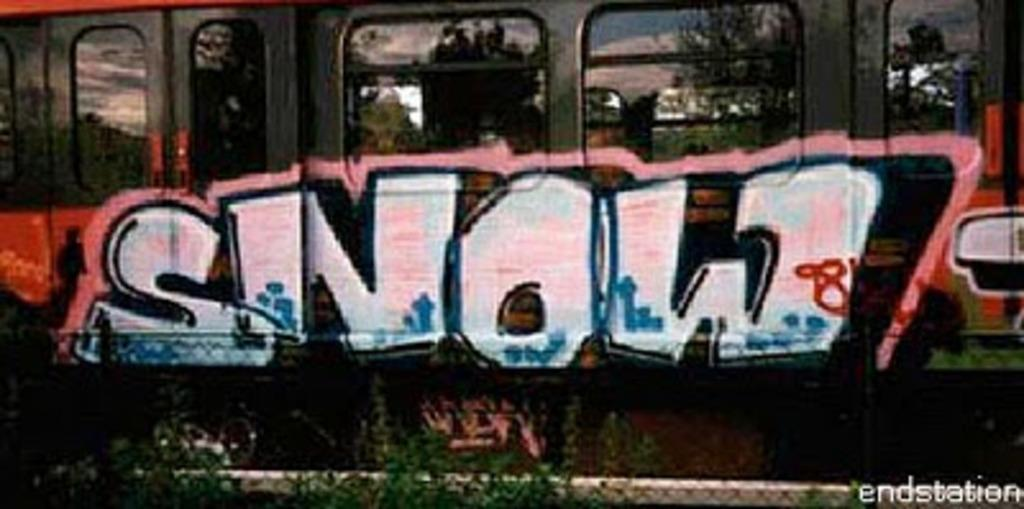<image>
Summarize the visual content of the image. Graffiti on a train that says the word "snow". 